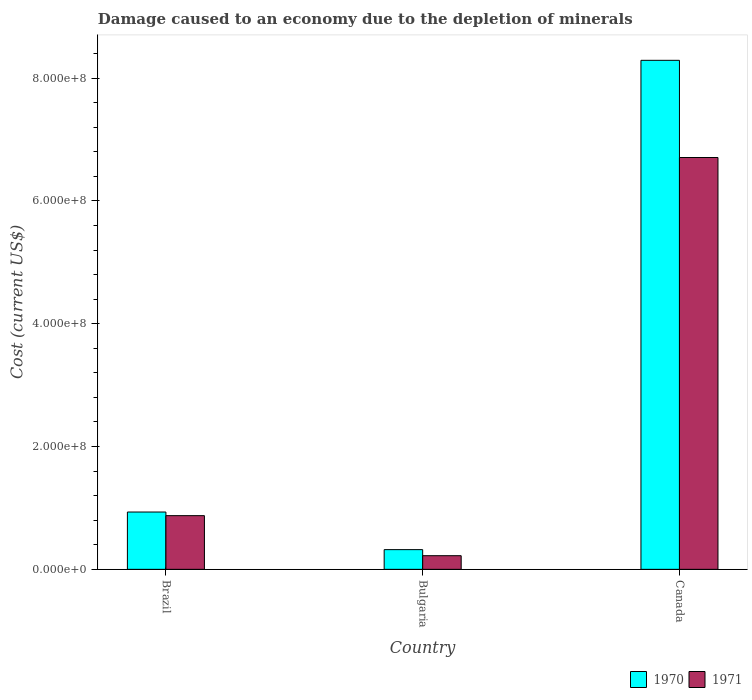How many groups of bars are there?
Provide a short and direct response. 3. Are the number of bars per tick equal to the number of legend labels?
Offer a terse response. Yes. Are the number of bars on each tick of the X-axis equal?
Offer a very short reply. Yes. How many bars are there on the 3rd tick from the left?
Ensure brevity in your answer.  2. What is the label of the 3rd group of bars from the left?
Your answer should be compact. Canada. In how many cases, is the number of bars for a given country not equal to the number of legend labels?
Give a very brief answer. 0. What is the cost of damage caused due to the depletion of minerals in 1971 in Canada?
Provide a succinct answer. 6.71e+08. Across all countries, what is the maximum cost of damage caused due to the depletion of minerals in 1970?
Offer a very short reply. 8.29e+08. Across all countries, what is the minimum cost of damage caused due to the depletion of minerals in 1971?
Offer a very short reply. 2.22e+07. In which country was the cost of damage caused due to the depletion of minerals in 1970 maximum?
Offer a very short reply. Canada. In which country was the cost of damage caused due to the depletion of minerals in 1971 minimum?
Offer a terse response. Bulgaria. What is the total cost of damage caused due to the depletion of minerals in 1971 in the graph?
Give a very brief answer. 7.80e+08. What is the difference between the cost of damage caused due to the depletion of minerals in 1971 in Bulgaria and that in Canada?
Ensure brevity in your answer.  -6.48e+08. What is the difference between the cost of damage caused due to the depletion of minerals in 1971 in Canada and the cost of damage caused due to the depletion of minerals in 1970 in Brazil?
Offer a very short reply. 5.77e+08. What is the average cost of damage caused due to the depletion of minerals in 1970 per country?
Make the answer very short. 3.18e+08. What is the difference between the cost of damage caused due to the depletion of minerals of/in 1971 and cost of damage caused due to the depletion of minerals of/in 1970 in Canada?
Offer a terse response. -1.58e+08. In how many countries, is the cost of damage caused due to the depletion of minerals in 1970 greater than 520000000 US$?
Offer a very short reply. 1. What is the ratio of the cost of damage caused due to the depletion of minerals in 1970 in Bulgaria to that in Canada?
Make the answer very short. 0.04. Is the difference between the cost of damage caused due to the depletion of minerals in 1971 in Bulgaria and Canada greater than the difference between the cost of damage caused due to the depletion of minerals in 1970 in Bulgaria and Canada?
Your answer should be very brief. Yes. What is the difference between the highest and the second highest cost of damage caused due to the depletion of minerals in 1970?
Your answer should be very brief. 7.97e+08. What is the difference between the highest and the lowest cost of damage caused due to the depletion of minerals in 1971?
Provide a short and direct response. 6.48e+08. Is the sum of the cost of damage caused due to the depletion of minerals in 1970 in Brazil and Canada greater than the maximum cost of damage caused due to the depletion of minerals in 1971 across all countries?
Provide a short and direct response. Yes. What does the 2nd bar from the right in Canada represents?
Make the answer very short. 1970. How many bars are there?
Provide a succinct answer. 6. Are all the bars in the graph horizontal?
Your answer should be compact. No. How many countries are there in the graph?
Ensure brevity in your answer.  3. Does the graph contain any zero values?
Provide a short and direct response. No. Does the graph contain grids?
Your response must be concise. No. How are the legend labels stacked?
Offer a terse response. Horizontal. What is the title of the graph?
Keep it short and to the point. Damage caused to an economy due to the depletion of minerals. What is the label or title of the Y-axis?
Give a very brief answer. Cost (current US$). What is the Cost (current US$) in 1970 in Brazil?
Keep it short and to the point. 9.33e+07. What is the Cost (current US$) of 1971 in Brazil?
Provide a succinct answer. 8.74e+07. What is the Cost (current US$) in 1970 in Bulgaria?
Offer a very short reply. 3.21e+07. What is the Cost (current US$) of 1971 in Bulgaria?
Give a very brief answer. 2.22e+07. What is the Cost (current US$) of 1970 in Canada?
Offer a terse response. 8.29e+08. What is the Cost (current US$) of 1971 in Canada?
Your answer should be very brief. 6.71e+08. Across all countries, what is the maximum Cost (current US$) in 1970?
Offer a terse response. 8.29e+08. Across all countries, what is the maximum Cost (current US$) of 1971?
Offer a very short reply. 6.71e+08. Across all countries, what is the minimum Cost (current US$) in 1970?
Make the answer very short. 3.21e+07. Across all countries, what is the minimum Cost (current US$) of 1971?
Your answer should be very brief. 2.22e+07. What is the total Cost (current US$) of 1970 in the graph?
Keep it short and to the point. 9.54e+08. What is the total Cost (current US$) of 1971 in the graph?
Give a very brief answer. 7.80e+08. What is the difference between the Cost (current US$) in 1970 in Brazil and that in Bulgaria?
Your answer should be compact. 6.12e+07. What is the difference between the Cost (current US$) in 1971 in Brazil and that in Bulgaria?
Provide a short and direct response. 6.52e+07. What is the difference between the Cost (current US$) in 1970 in Brazil and that in Canada?
Your response must be concise. -7.36e+08. What is the difference between the Cost (current US$) in 1971 in Brazil and that in Canada?
Provide a succinct answer. -5.83e+08. What is the difference between the Cost (current US$) of 1970 in Bulgaria and that in Canada?
Your answer should be compact. -7.97e+08. What is the difference between the Cost (current US$) of 1971 in Bulgaria and that in Canada?
Offer a very short reply. -6.48e+08. What is the difference between the Cost (current US$) in 1970 in Brazil and the Cost (current US$) in 1971 in Bulgaria?
Make the answer very short. 7.11e+07. What is the difference between the Cost (current US$) in 1970 in Brazil and the Cost (current US$) in 1971 in Canada?
Your response must be concise. -5.77e+08. What is the difference between the Cost (current US$) in 1970 in Bulgaria and the Cost (current US$) in 1971 in Canada?
Your response must be concise. -6.39e+08. What is the average Cost (current US$) of 1970 per country?
Provide a succinct answer. 3.18e+08. What is the average Cost (current US$) in 1971 per country?
Give a very brief answer. 2.60e+08. What is the difference between the Cost (current US$) in 1970 and Cost (current US$) in 1971 in Brazil?
Your answer should be very brief. 5.90e+06. What is the difference between the Cost (current US$) in 1970 and Cost (current US$) in 1971 in Bulgaria?
Offer a terse response. 9.88e+06. What is the difference between the Cost (current US$) in 1970 and Cost (current US$) in 1971 in Canada?
Provide a short and direct response. 1.58e+08. What is the ratio of the Cost (current US$) in 1970 in Brazil to that in Bulgaria?
Provide a short and direct response. 2.91. What is the ratio of the Cost (current US$) in 1971 in Brazil to that in Bulgaria?
Provide a short and direct response. 3.94. What is the ratio of the Cost (current US$) in 1970 in Brazil to that in Canada?
Provide a succinct answer. 0.11. What is the ratio of the Cost (current US$) of 1971 in Brazil to that in Canada?
Make the answer very short. 0.13. What is the ratio of the Cost (current US$) of 1970 in Bulgaria to that in Canada?
Provide a short and direct response. 0.04. What is the ratio of the Cost (current US$) of 1971 in Bulgaria to that in Canada?
Give a very brief answer. 0.03. What is the difference between the highest and the second highest Cost (current US$) of 1970?
Provide a succinct answer. 7.36e+08. What is the difference between the highest and the second highest Cost (current US$) of 1971?
Your response must be concise. 5.83e+08. What is the difference between the highest and the lowest Cost (current US$) in 1970?
Your response must be concise. 7.97e+08. What is the difference between the highest and the lowest Cost (current US$) of 1971?
Your answer should be compact. 6.48e+08. 